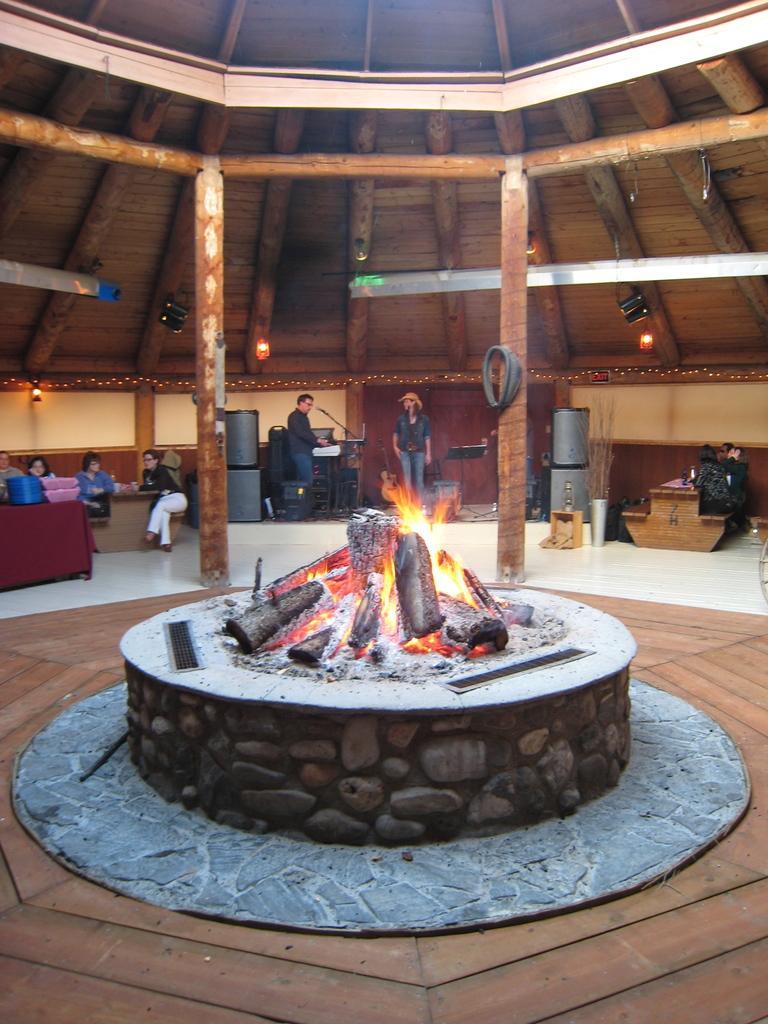Could you give a brief overview of what you see in this image? Here we can see few persons, lights, and tables. This is fire and there are poles. 